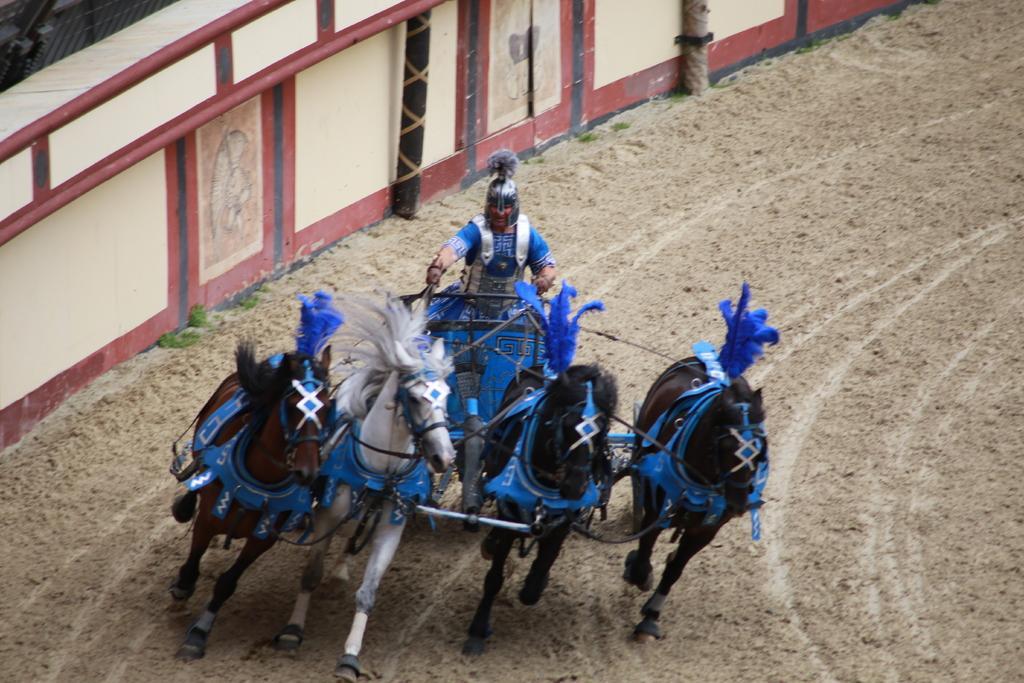Can you describe this image briefly? In this image we can see a man sitting on the horse cart. At the bottom there is sand. In the background there is a wall. 